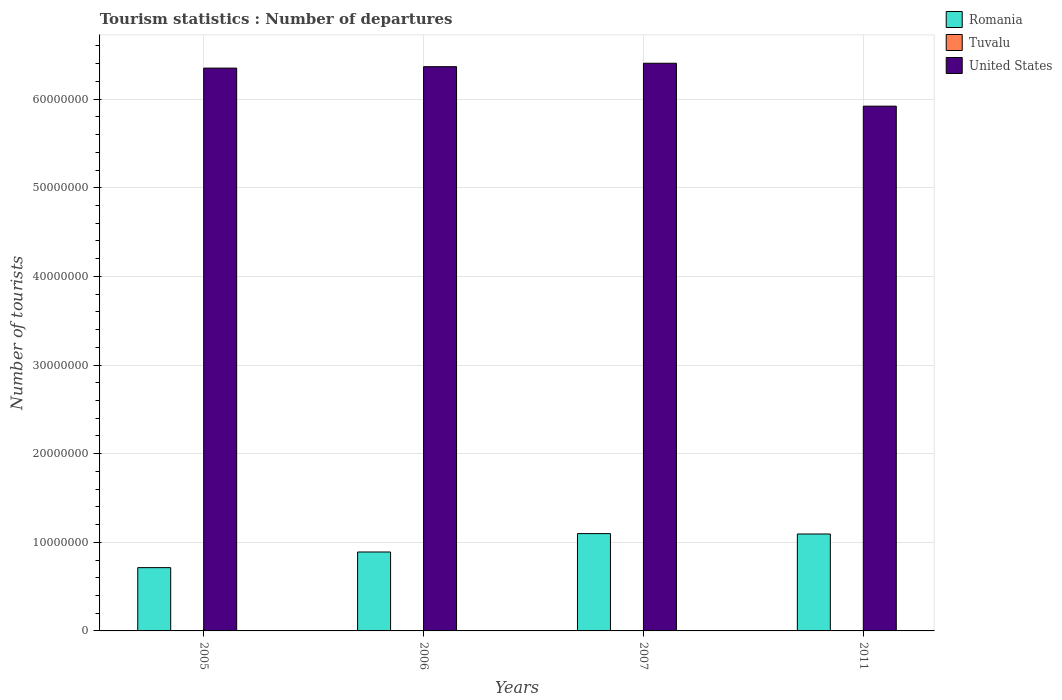Are the number of bars per tick equal to the number of legend labels?
Keep it short and to the point. Yes. Are the number of bars on each tick of the X-axis equal?
Provide a succinct answer. Yes. How many bars are there on the 3rd tick from the left?
Offer a terse response. 3. What is the label of the 1st group of bars from the left?
Keep it short and to the point. 2005. What is the number of tourist departures in United States in 2005?
Offer a terse response. 6.35e+07. Across all years, what is the maximum number of tourist departures in Tuvalu?
Offer a terse response. 2400. Across all years, what is the minimum number of tourist departures in Romania?
Offer a very short reply. 7.14e+06. In which year was the number of tourist departures in Romania minimum?
Your answer should be very brief. 2005. What is the total number of tourist departures in Romania in the graph?
Give a very brief answer. 3.80e+07. What is the difference between the number of tourist departures in Romania in 2006 and that in 2011?
Give a very brief answer. -2.03e+06. What is the difference between the number of tourist departures in United States in 2007 and the number of tourist departures in Tuvalu in 2006?
Offer a very short reply. 6.40e+07. What is the average number of tourist departures in United States per year?
Provide a short and direct response. 6.26e+07. In the year 2005, what is the difference between the number of tourist departures in United States and number of tourist departures in Romania?
Your answer should be compact. 5.64e+07. In how many years, is the number of tourist departures in Tuvalu greater than 26000000?
Offer a very short reply. 0. What is the ratio of the number of tourist departures in United States in 2005 to that in 2007?
Make the answer very short. 0.99. What is the difference between the highest and the second highest number of tourist departures in Romania?
Ensure brevity in your answer.  4.40e+04. What is the difference between the highest and the lowest number of tourist departures in Romania?
Your answer should be compact. 3.84e+06. What does the 3rd bar from the left in 2011 represents?
Your answer should be compact. United States. What does the 1st bar from the right in 2011 represents?
Offer a very short reply. United States. How many bars are there?
Offer a very short reply. 12. How many years are there in the graph?
Your response must be concise. 4. What is the difference between two consecutive major ticks on the Y-axis?
Provide a succinct answer. 1.00e+07. Does the graph contain any zero values?
Your answer should be very brief. No. Where does the legend appear in the graph?
Give a very brief answer. Top right. How many legend labels are there?
Your response must be concise. 3. What is the title of the graph?
Offer a very short reply. Tourism statistics : Number of departures. Does "South Asia" appear as one of the legend labels in the graph?
Ensure brevity in your answer.  No. What is the label or title of the X-axis?
Provide a succinct answer. Years. What is the label or title of the Y-axis?
Ensure brevity in your answer.  Number of tourists. What is the Number of tourists of Romania in 2005?
Make the answer very short. 7.14e+06. What is the Number of tourists in Tuvalu in 2005?
Make the answer very short. 2200. What is the Number of tourists of United States in 2005?
Give a very brief answer. 6.35e+07. What is the Number of tourists of Romania in 2006?
Keep it short and to the point. 8.91e+06. What is the Number of tourists of United States in 2006?
Offer a very short reply. 6.37e+07. What is the Number of tourists of Romania in 2007?
Your answer should be very brief. 1.10e+07. What is the Number of tourists in Tuvalu in 2007?
Your response must be concise. 2400. What is the Number of tourists in United States in 2007?
Keep it short and to the point. 6.40e+07. What is the Number of tourists of Romania in 2011?
Offer a very short reply. 1.09e+07. What is the Number of tourists in Tuvalu in 2011?
Give a very brief answer. 2100. What is the Number of tourists in United States in 2011?
Provide a short and direct response. 5.92e+07. Across all years, what is the maximum Number of tourists in Romania?
Offer a terse response. 1.10e+07. Across all years, what is the maximum Number of tourists of Tuvalu?
Offer a terse response. 2400. Across all years, what is the maximum Number of tourists in United States?
Your response must be concise. 6.40e+07. Across all years, what is the minimum Number of tourists of Romania?
Ensure brevity in your answer.  7.14e+06. Across all years, what is the minimum Number of tourists in Tuvalu?
Offer a terse response. 2000. Across all years, what is the minimum Number of tourists of United States?
Offer a very short reply. 5.92e+07. What is the total Number of tourists of Romania in the graph?
Your answer should be very brief. 3.80e+07. What is the total Number of tourists of Tuvalu in the graph?
Provide a short and direct response. 8700. What is the total Number of tourists of United States in the graph?
Your answer should be very brief. 2.50e+08. What is the difference between the Number of tourists in Romania in 2005 and that in 2006?
Your answer should be compact. -1.77e+06. What is the difference between the Number of tourists of United States in 2005 and that in 2006?
Your response must be concise. -1.60e+05. What is the difference between the Number of tourists of Romania in 2005 and that in 2007?
Make the answer very short. -3.84e+06. What is the difference between the Number of tourists in Tuvalu in 2005 and that in 2007?
Keep it short and to the point. -200. What is the difference between the Number of tourists of United States in 2005 and that in 2007?
Ensure brevity in your answer.  -5.46e+05. What is the difference between the Number of tourists in Romania in 2005 and that in 2011?
Give a very brief answer. -3.80e+06. What is the difference between the Number of tourists of Tuvalu in 2005 and that in 2011?
Offer a terse response. 100. What is the difference between the Number of tourists of United States in 2005 and that in 2011?
Keep it short and to the point. 4.29e+06. What is the difference between the Number of tourists in Romania in 2006 and that in 2007?
Make the answer very short. -2.07e+06. What is the difference between the Number of tourists of Tuvalu in 2006 and that in 2007?
Provide a succinct answer. -400. What is the difference between the Number of tourists of United States in 2006 and that in 2007?
Offer a very short reply. -3.86e+05. What is the difference between the Number of tourists of Romania in 2006 and that in 2011?
Keep it short and to the point. -2.03e+06. What is the difference between the Number of tourists of Tuvalu in 2006 and that in 2011?
Offer a terse response. -100. What is the difference between the Number of tourists in United States in 2006 and that in 2011?
Your answer should be compact. 4.45e+06. What is the difference between the Number of tourists in Romania in 2007 and that in 2011?
Provide a succinct answer. 4.40e+04. What is the difference between the Number of tourists in Tuvalu in 2007 and that in 2011?
Give a very brief answer. 300. What is the difference between the Number of tourists of United States in 2007 and that in 2011?
Your answer should be very brief. 4.84e+06. What is the difference between the Number of tourists of Romania in 2005 and the Number of tourists of Tuvalu in 2006?
Your response must be concise. 7.14e+06. What is the difference between the Number of tourists in Romania in 2005 and the Number of tourists in United States in 2006?
Ensure brevity in your answer.  -5.65e+07. What is the difference between the Number of tourists of Tuvalu in 2005 and the Number of tourists of United States in 2006?
Provide a succinct answer. -6.37e+07. What is the difference between the Number of tourists in Romania in 2005 and the Number of tourists in Tuvalu in 2007?
Offer a very short reply. 7.14e+06. What is the difference between the Number of tourists of Romania in 2005 and the Number of tourists of United States in 2007?
Offer a very short reply. -5.69e+07. What is the difference between the Number of tourists in Tuvalu in 2005 and the Number of tourists in United States in 2007?
Offer a terse response. -6.40e+07. What is the difference between the Number of tourists of Romania in 2005 and the Number of tourists of Tuvalu in 2011?
Offer a very short reply. 7.14e+06. What is the difference between the Number of tourists of Romania in 2005 and the Number of tourists of United States in 2011?
Ensure brevity in your answer.  -5.21e+07. What is the difference between the Number of tourists in Tuvalu in 2005 and the Number of tourists in United States in 2011?
Your response must be concise. -5.92e+07. What is the difference between the Number of tourists in Romania in 2006 and the Number of tourists in Tuvalu in 2007?
Your response must be concise. 8.90e+06. What is the difference between the Number of tourists of Romania in 2006 and the Number of tourists of United States in 2007?
Make the answer very short. -5.51e+07. What is the difference between the Number of tourists of Tuvalu in 2006 and the Number of tourists of United States in 2007?
Offer a terse response. -6.40e+07. What is the difference between the Number of tourists of Romania in 2006 and the Number of tourists of Tuvalu in 2011?
Ensure brevity in your answer.  8.90e+06. What is the difference between the Number of tourists in Romania in 2006 and the Number of tourists in United States in 2011?
Give a very brief answer. -5.03e+07. What is the difference between the Number of tourists in Tuvalu in 2006 and the Number of tourists in United States in 2011?
Your response must be concise. -5.92e+07. What is the difference between the Number of tourists of Romania in 2007 and the Number of tourists of Tuvalu in 2011?
Your answer should be compact. 1.10e+07. What is the difference between the Number of tourists of Romania in 2007 and the Number of tourists of United States in 2011?
Make the answer very short. -4.82e+07. What is the difference between the Number of tourists in Tuvalu in 2007 and the Number of tourists in United States in 2011?
Keep it short and to the point. -5.92e+07. What is the average Number of tourists in Romania per year?
Your response must be concise. 9.49e+06. What is the average Number of tourists in Tuvalu per year?
Your answer should be compact. 2175. What is the average Number of tourists of United States per year?
Give a very brief answer. 6.26e+07. In the year 2005, what is the difference between the Number of tourists in Romania and Number of tourists in Tuvalu?
Give a very brief answer. 7.14e+06. In the year 2005, what is the difference between the Number of tourists in Romania and Number of tourists in United States?
Your answer should be very brief. -5.64e+07. In the year 2005, what is the difference between the Number of tourists in Tuvalu and Number of tourists in United States?
Keep it short and to the point. -6.35e+07. In the year 2006, what is the difference between the Number of tourists of Romania and Number of tourists of Tuvalu?
Keep it short and to the point. 8.90e+06. In the year 2006, what is the difference between the Number of tourists of Romania and Number of tourists of United States?
Your answer should be very brief. -5.48e+07. In the year 2006, what is the difference between the Number of tourists in Tuvalu and Number of tourists in United States?
Keep it short and to the point. -6.37e+07. In the year 2007, what is the difference between the Number of tourists in Romania and Number of tourists in Tuvalu?
Your response must be concise. 1.10e+07. In the year 2007, what is the difference between the Number of tourists of Romania and Number of tourists of United States?
Your answer should be compact. -5.31e+07. In the year 2007, what is the difference between the Number of tourists in Tuvalu and Number of tourists in United States?
Offer a terse response. -6.40e+07. In the year 2011, what is the difference between the Number of tourists of Romania and Number of tourists of Tuvalu?
Ensure brevity in your answer.  1.09e+07. In the year 2011, what is the difference between the Number of tourists in Romania and Number of tourists in United States?
Ensure brevity in your answer.  -4.83e+07. In the year 2011, what is the difference between the Number of tourists in Tuvalu and Number of tourists in United States?
Keep it short and to the point. -5.92e+07. What is the ratio of the Number of tourists in Romania in 2005 to that in 2006?
Your answer should be compact. 0.8. What is the ratio of the Number of tourists in Romania in 2005 to that in 2007?
Offer a terse response. 0.65. What is the ratio of the Number of tourists in Tuvalu in 2005 to that in 2007?
Your response must be concise. 0.92. What is the ratio of the Number of tourists in United States in 2005 to that in 2007?
Your answer should be compact. 0.99. What is the ratio of the Number of tourists of Romania in 2005 to that in 2011?
Offer a terse response. 0.65. What is the ratio of the Number of tourists of Tuvalu in 2005 to that in 2011?
Keep it short and to the point. 1.05. What is the ratio of the Number of tourists in United States in 2005 to that in 2011?
Offer a terse response. 1.07. What is the ratio of the Number of tourists in Romania in 2006 to that in 2007?
Your answer should be very brief. 0.81. What is the ratio of the Number of tourists in United States in 2006 to that in 2007?
Offer a very short reply. 0.99. What is the ratio of the Number of tourists of Romania in 2006 to that in 2011?
Your response must be concise. 0.81. What is the ratio of the Number of tourists of Tuvalu in 2006 to that in 2011?
Your answer should be compact. 0.95. What is the ratio of the Number of tourists in United States in 2006 to that in 2011?
Your answer should be very brief. 1.08. What is the ratio of the Number of tourists of United States in 2007 to that in 2011?
Offer a very short reply. 1.08. What is the difference between the highest and the second highest Number of tourists in Romania?
Provide a short and direct response. 4.40e+04. What is the difference between the highest and the second highest Number of tourists in United States?
Keep it short and to the point. 3.86e+05. What is the difference between the highest and the lowest Number of tourists in Romania?
Make the answer very short. 3.84e+06. What is the difference between the highest and the lowest Number of tourists of United States?
Your response must be concise. 4.84e+06. 